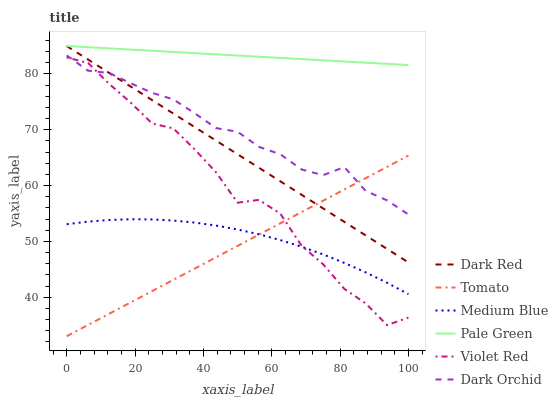Does Tomato have the minimum area under the curve?
Answer yes or no. Yes. Does Pale Green have the maximum area under the curve?
Answer yes or no. Yes. Does Violet Red have the minimum area under the curve?
Answer yes or no. No. Does Violet Red have the maximum area under the curve?
Answer yes or no. No. Is Tomato the smoothest?
Answer yes or no. Yes. Is Violet Red the roughest?
Answer yes or no. Yes. Is Dark Red the smoothest?
Answer yes or no. No. Is Dark Red the roughest?
Answer yes or no. No. Does Tomato have the lowest value?
Answer yes or no. Yes. Does Violet Red have the lowest value?
Answer yes or no. No. Does Pale Green have the highest value?
Answer yes or no. Yes. Does Violet Red have the highest value?
Answer yes or no. No. Is Violet Red less than Dark Red?
Answer yes or no. Yes. Is Pale Green greater than Violet Red?
Answer yes or no. Yes. Does Tomato intersect Dark Orchid?
Answer yes or no. Yes. Is Tomato less than Dark Orchid?
Answer yes or no. No. Is Tomato greater than Dark Orchid?
Answer yes or no. No. Does Violet Red intersect Dark Red?
Answer yes or no. No. 